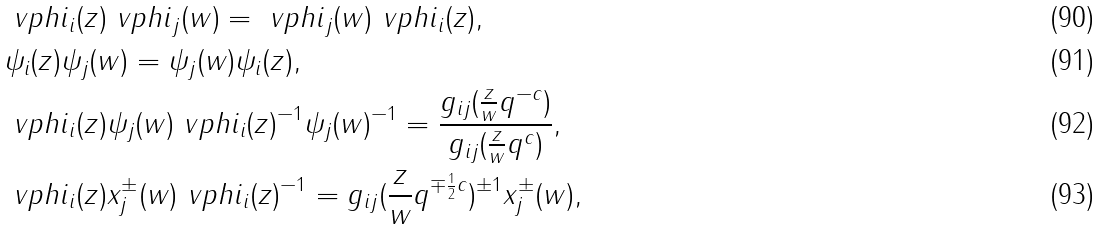<formula> <loc_0><loc_0><loc_500><loc_500>& \ v p h i _ { i } ( z ) \ v p h i _ { j } ( w ) = \ v p h i _ { j } ( w ) \ v p h i _ { i } ( z ) , \\ & \psi _ { i } ( z ) \psi _ { j } ( w ) = \psi _ { j } ( w ) \psi _ { i } ( z ) , \\ & \ v p h i _ { i } ( z ) \psi _ { j } ( w ) \ v p h i _ { i } ( z ) ^ { - 1 } \psi _ { j } ( w ) ^ { - 1 } = \frac { g _ { i j } ( \frac { z } { w } q ^ { - c } ) } { g _ { i j } ( \frac { z } { w } q ^ { c } ) } , \\ & \ v p h i _ { i } ( z ) x _ { j } ^ { \pm } ( w ) \ v p h i _ { i } ( z ) ^ { - 1 } = g _ { i j } ( \frac { z } { w } q ^ { \mp \frac { 1 } { 2 } c } ) ^ { \pm 1 } x _ { j } ^ { \pm } ( w ) ,</formula> 